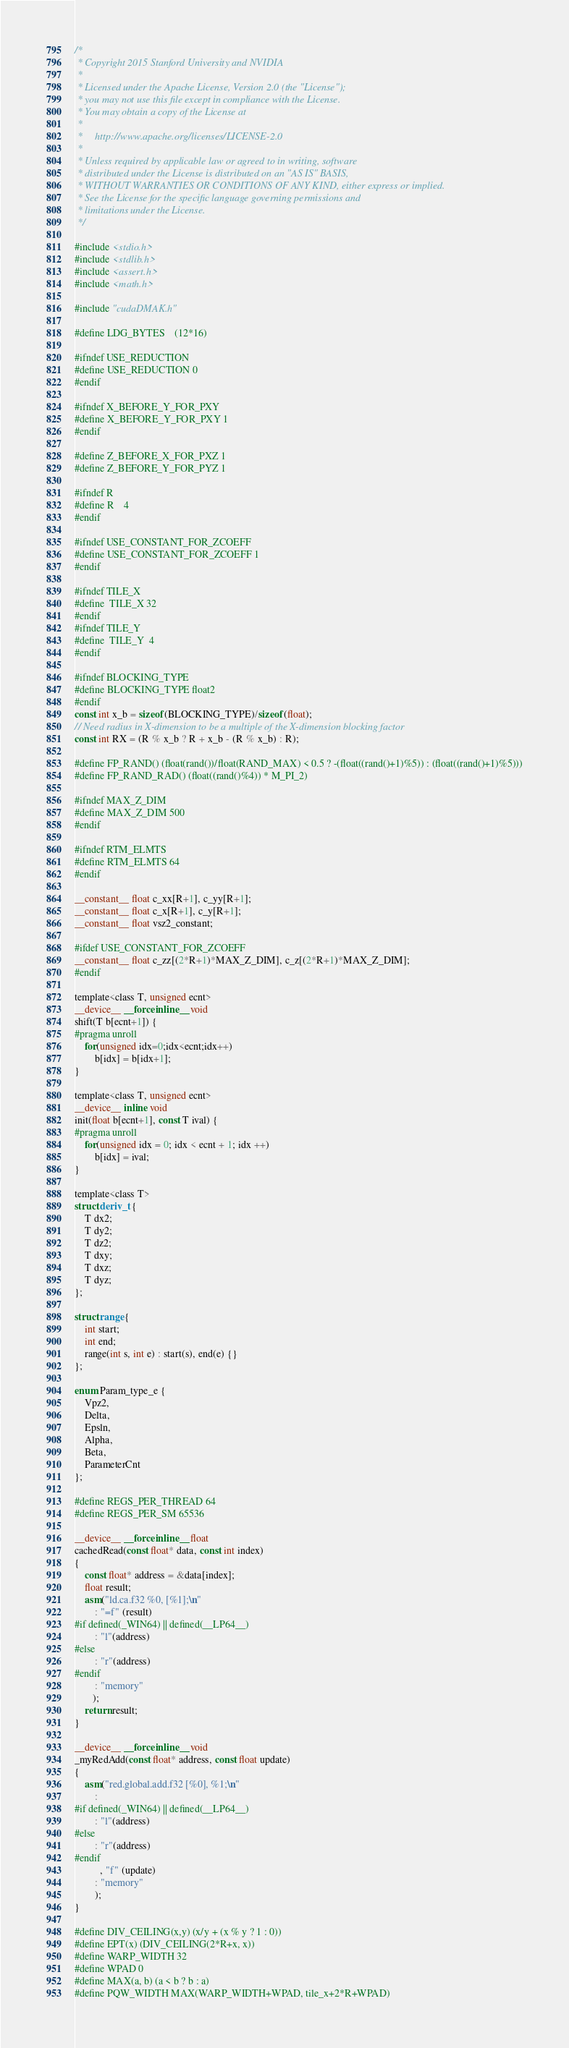<code> <loc_0><loc_0><loc_500><loc_500><_Cuda_>/*
 * Copyright 2015 Stanford University and NVIDIA
 *
 * Licensed under the Apache License, Version 2.0 (the "License");
 * you may not use this file except in compliance with the License.
 * You may obtain a copy of the License at
 *
 *     http://www.apache.org/licenses/LICENSE-2.0
 *
 * Unless required by applicable law or agreed to in writing, software
 * distributed under the License is distributed on an "AS IS" BASIS,
 * WITHOUT WARRANTIES OR CONDITIONS OF ANY KIND, either express or implied.
 * See the License for the specific language governing permissions and
 * limitations under the License.
 */

#include <stdio.h>
#include <stdlib.h>
#include <assert.h>
#include <math.h>

#include "cudaDMAK.h"

#define LDG_BYTES	(12*16)

#ifndef USE_REDUCTION
#define USE_REDUCTION 0
#endif

#ifndef X_BEFORE_Y_FOR_PXY
#define X_BEFORE_Y_FOR_PXY 1
#endif

#define Z_BEFORE_X_FOR_PXZ 1
#define Z_BEFORE_Y_FOR_PYZ 1

#ifndef R
#define R	4
#endif

#ifndef USE_CONSTANT_FOR_ZCOEFF
#define USE_CONSTANT_FOR_ZCOEFF 1
#endif

#ifndef TILE_X
#define	TILE_X 32	
#endif
#ifndef TILE_Y
#define	TILE_Y	4		
#endif

#ifndef BLOCKING_TYPE
#define BLOCKING_TYPE float2
#endif
const int x_b = sizeof(BLOCKING_TYPE)/sizeof(float);
// Need radius in X-dimension to be a multiple of the X-dimension blocking factor
const int RX = (R % x_b ? R + x_b - (R % x_b) : R);

#define FP_RAND() (float(rand())/float(RAND_MAX) < 0.5 ? -(float((rand()+1)%5)) : (float((rand()+1)%5)))
#define FP_RAND_RAD() (float((rand()%4)) * M_PI_2)

#ifndef MAX_Z_DIM
#define MAX_Z_DIM 500
#endif

#ifndef RTM_ELMTS
#define RTM_ELMTS 64
#endif

__constant__ float c_xx[R+1], c_yy[R+1];
__constant__ float c_x[R+1], c_y[R+1];
__constant__ float vsz2_constant;

#ifdef USE_CONSTANT_FOR_ZCOEFF
__constant__ float c_zz[(2*R+1)*MAX_Z_DIM], c_z[(2*R+1)*MAX_Z_DIM];
#endif

template<class T, unsigned ecnt>
__device__ __forceinline__ void
shift(T b[ecnt+1]) {
#pragma unroll
    for(unsigned idx=0;idx<ecnt;idx++)
        b[idx] = b[idx+1];
}

template<class T, unsigned ecnt>
__device__ inline void
init(float b[ecnt+1], const T ival) {
#pragma unroll
    for(unsigned idx = 0; idx < ecnt + 1; idx ++)
        b[idx] = ival;
}

template<class T>
struct deriv_t {
    T dx2;
    T dy2;
    T dz2;
    T dxy;
    T dxz;
    T dyz;
};

struct range {
    int start;
    int end;
    range(int s, int e) : start(s), end(e) {}
};

enum Param_type_e {
    Vpz2,
    Delta,
    Epsln,
    Alpha,
    Beta,
    ParameterCnt
};

#define REGS_PER_THREAD 64
#define REGS_PER_SM 65536

__device__ __forceinline__ float
cachedRead(const float* data, const int index)
{
    const float* address = &data[index];
    float result;
    asm("ld.ca.f32 %0, [%1];\n"
        : "=f" (result)
#if defined(_WIN64) || defined(__LP64__)
        : "l"(address)
#else
        : "r"(address)
#endif
        : "memory"
       );
    return result;
}

__device__ __forceinline__ void
_myRedAdd(const float* address, const float update)
{
    asm("red.global.add.f32 [%0], %1;\n"
        :
#if defined(_WIN64) || defined(__LP64__)
        : "l"(address)
#else
        : "r"(address)
#endif
          , "f" (update)
        : "memory"
        );
}

#define DIV_CEILING(x,y) (x/y + (x % y ? 1 : 0))
#define EPT(x) (DIV_CEILING(2*R+x, x))
#define WARP_WIDTH 32
#define WPAD 0
#define MAX(a, b) (a < b ? b : a)
#define PQW_WIDTH MAX(WARP_WIDTH+WPAD, tile_x+2*R+WPAD)</code> 